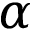<formula> <loc_0><loc_0><loc_500><loc_500>\alpha ^ { \ t h }</formula> 